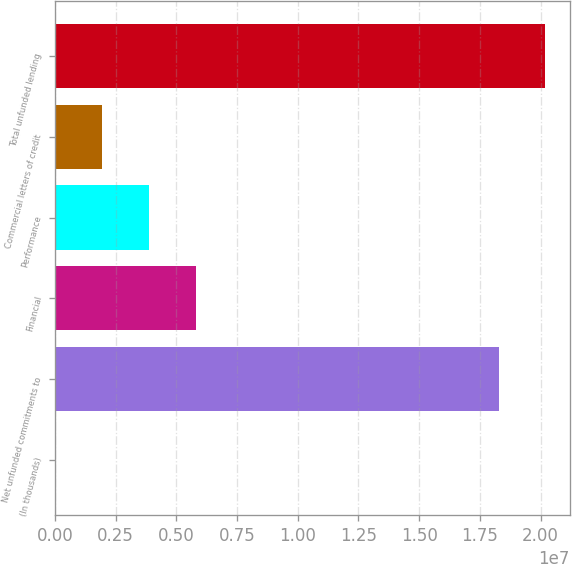Convert chart. <chart><loc_0><loc_0><loc_500><loc_500><bar_chart><fcel>(In thousands)<fcel>Net unfunded commitments to<fcel>Financial<fcel>Performance<fcel>Commercial letters of credit<fcel>Total unfunded lending<nl><fcel>2016<fcel>1.82737e+07<fcel>5.79164e+06<fcel>3.86176e+06<fcel>1.93189e+06<fcel>2.02036e+07<nl></chart> 